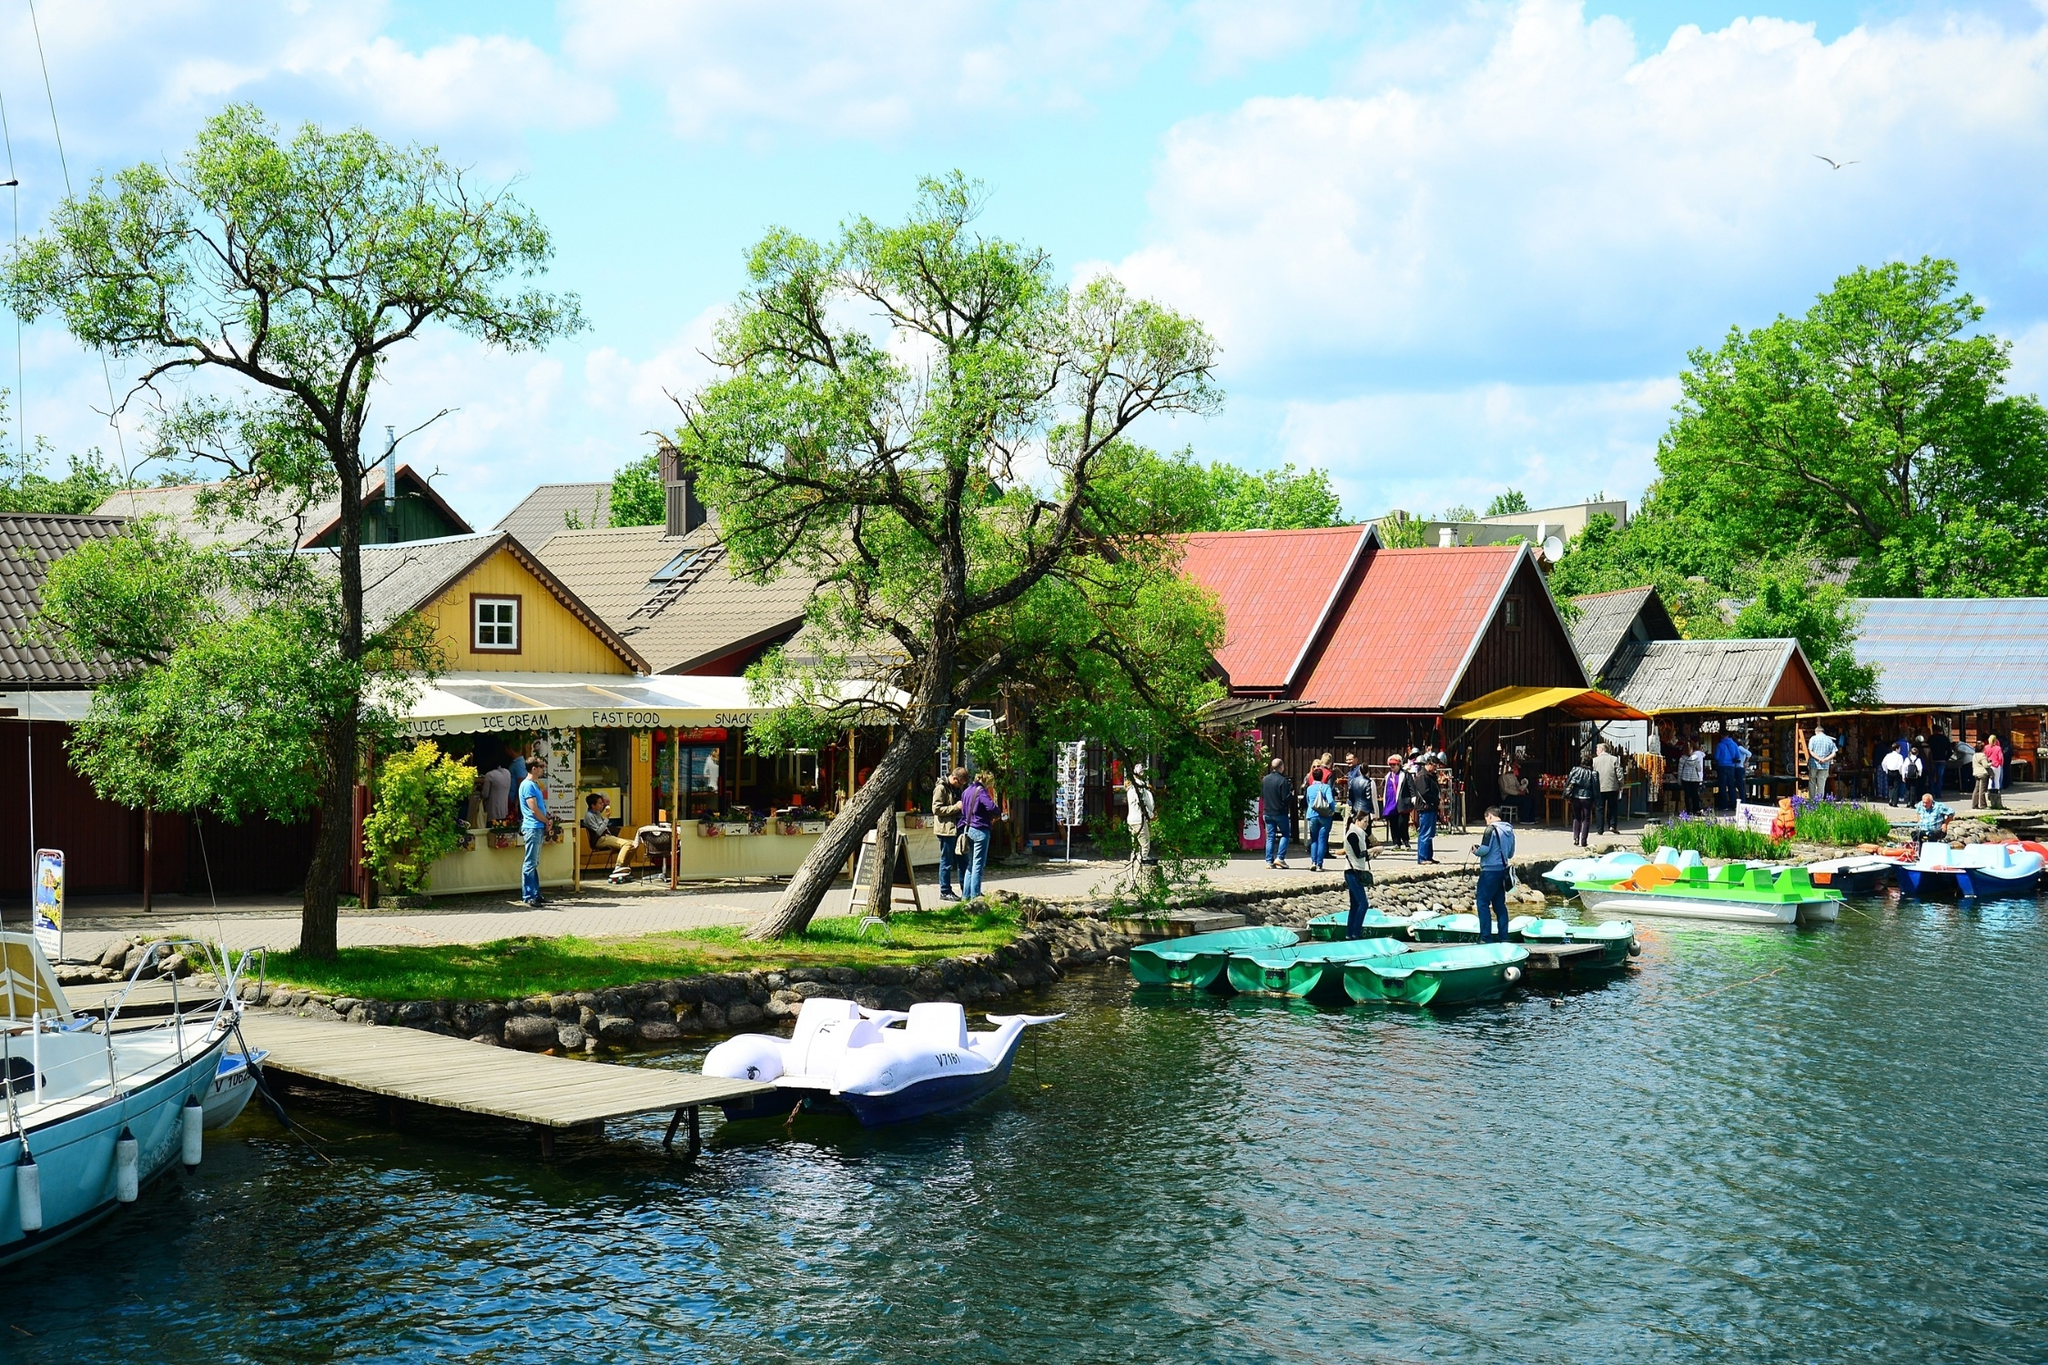Create a fictional story involving this village. Once upon a time, in the quaint village by the lake, the villagers discovered a mystical secret hidden within the forest surrounding their home. Each night, the trees in the forest would glow faintly, leading to a mysterious cave that held the legendary 'Crystal of Everglow.' Legend had it that whoever found the crystal would bring eternal prosperity to the village. One day, a curious young girl named Elara, noticing the glowing trees, decided to venture into the forest following the faint light. After hours of wandering through the enchanted woods, she stumbled upon the shimmering cave. Inside, she found the radiant Crystal of Everglow. When she brought the crystal back to the village, its light spread throughout, illuminating the village with a warm, magical glow. From that day, the village flourished beyond anyone’s imagination, becoming a haven for travelers from far and wide, all drawn to the mystical charm of Elara's discovery. 